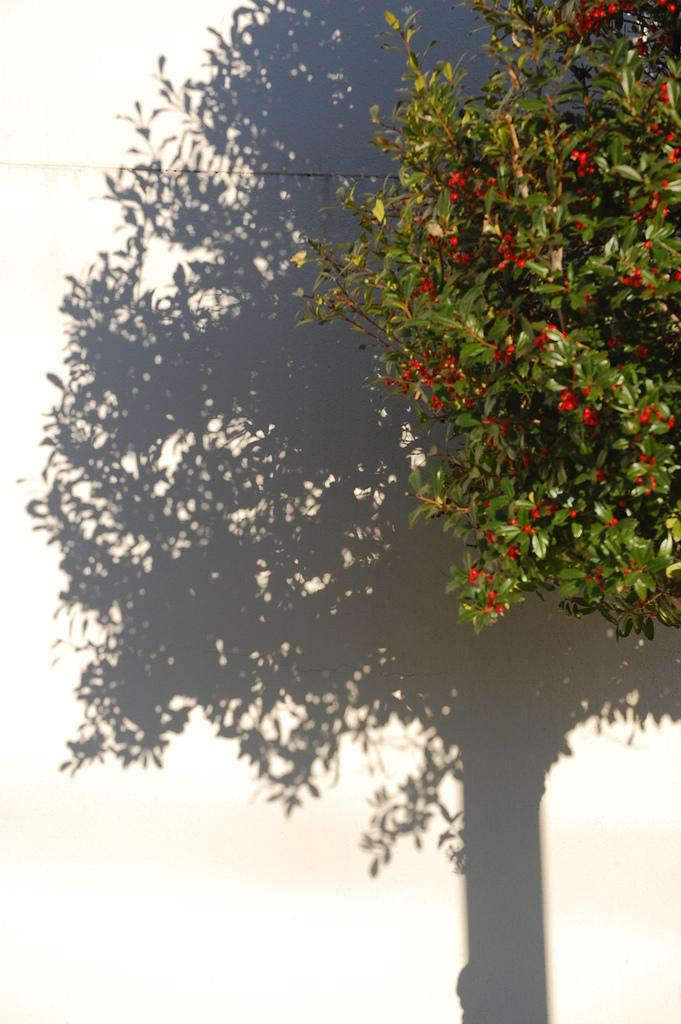What type of plant is in the image? There is a plant with red flowers in the image. Where is the plant located in the image? The plant is on the right side of the image. What can be seen in the background of the image? There is a wall in the background of the image. What is the shadow of in the image? There is a shadow of a tree on the wall. Who is offering a committee meeting in the image? There is no reference to a committee meeting or an offer in the image. 